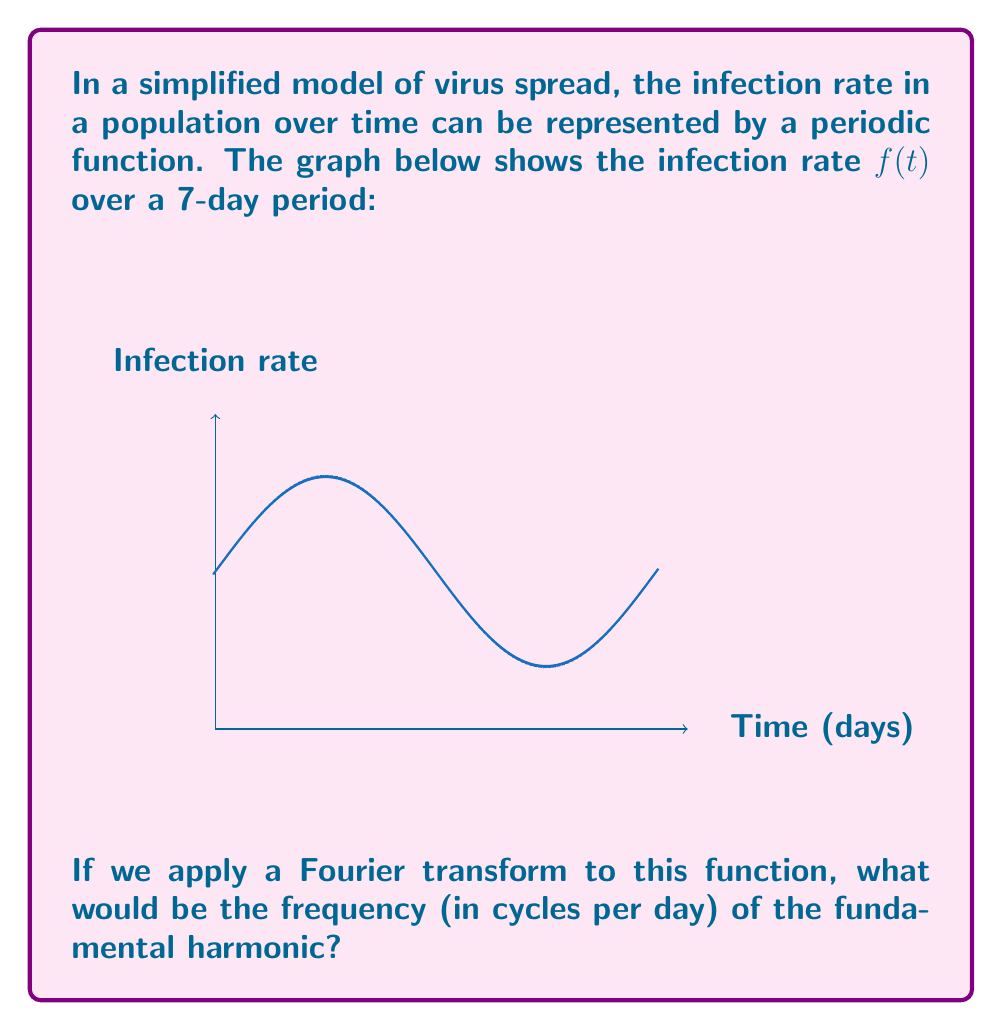Provide a solution to this math problem. Let's approach this step-by-step:

1) The Fourier transform decomposes a function into its constituent frequencies. The fundamental harmonic is the lowest frequency component that completes one full cycle over the period of the function.

2) From the graph, we can see that the function completes one full cycle in 7 days. This is our fundamental period, $T$.

3) The frequency $f$ is the inverse of the period:

   $$f = \frac{1}{T}$$

4) Substituting our period of 7 days:

   $$f = \frac{1}{7} \text{ cycles/day}$$

5) This means that in one day, $\frac{1}{7}$ of a cycle is completed.

6) The Fourier transform would show a peak at this frequency, representing the fundamental harmonic of the infection rate function.

Note: In a more complex model, there might be additional harmonics at integer multiples of this fundamental frequency, but the question asks specifically about the fundamental harmonic.
Answer: $\frac{1}{7}$ cycles/day 